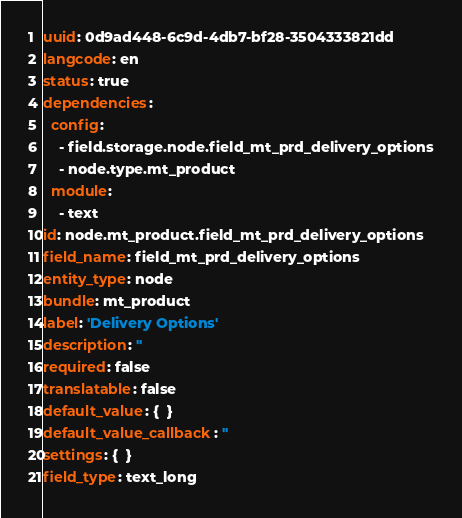Convert code to text. <code><loc_0><loc_0><loc_500><loc_500><_YAML_>uuid: 0d9ad448-6c9d-4db7-bf28-3504333821dd
langcode: en
status: true
dependencies:
  config:
    - field.storage.node.field_mt_prd_delivery_options
    - node.type.mt_product
  module:
    - text
id: node.mt_product.field_mt_prd_delivery_options
field_name: field_mt_prd_delivery_options
entity_type: node
bundle: mt_product
label: 'Delivery Options'
description: ''
required: false
translatable: false
default_value: {  }
default_value_callback: ''
settings: {  }
field_type: text_long
</code> 